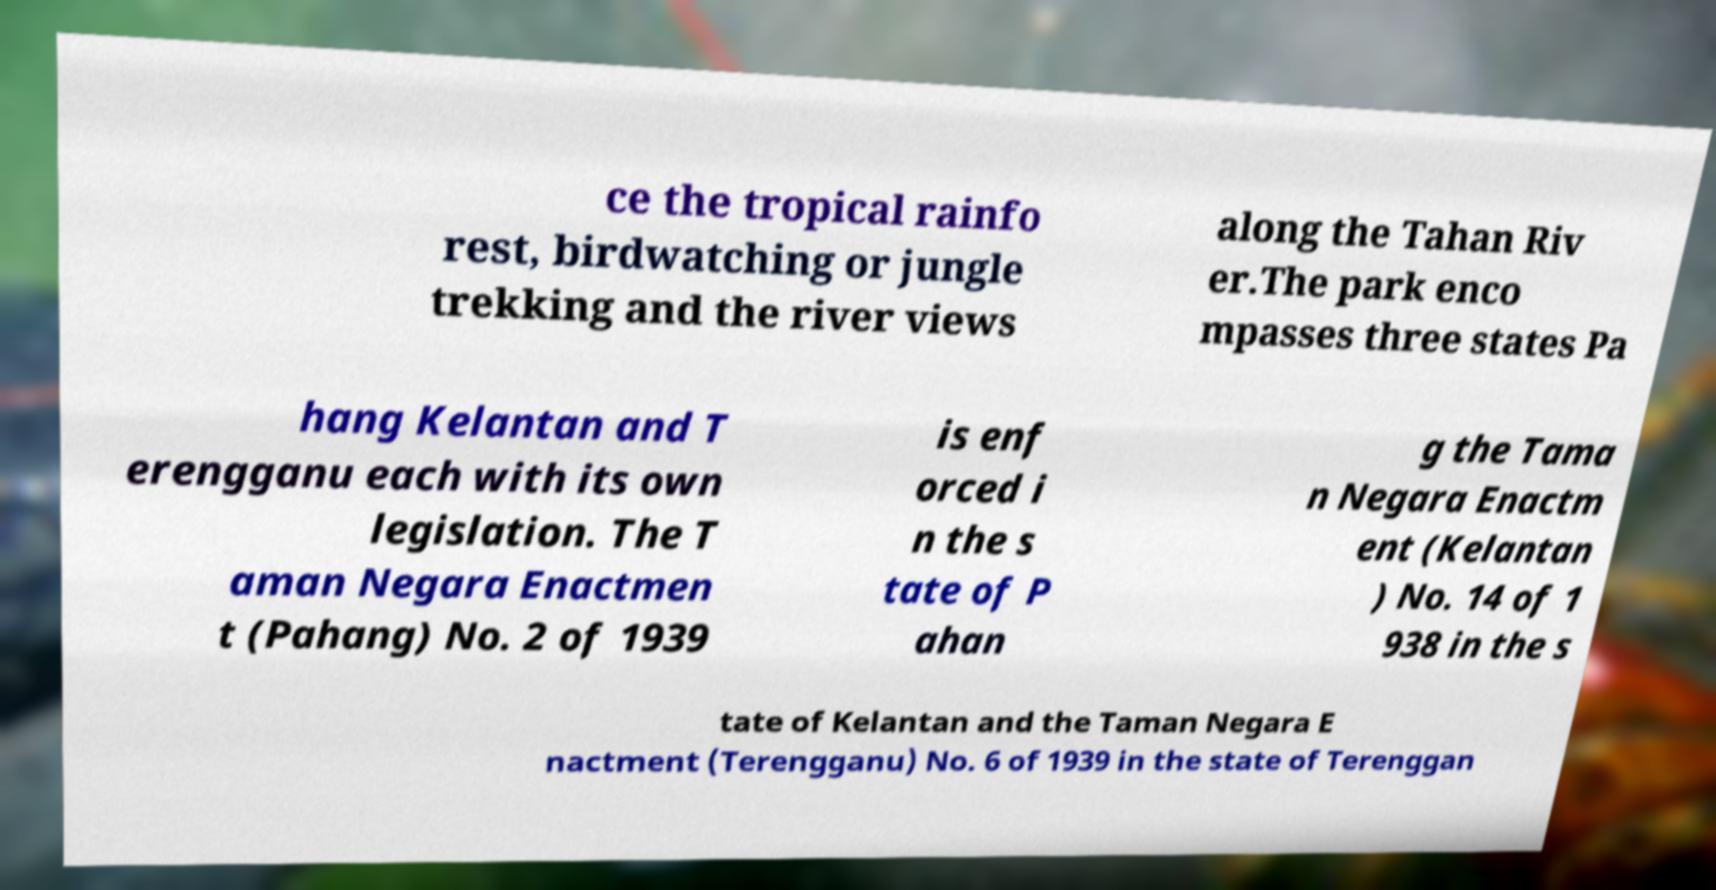Please read and relay the text visible in this image. What does it say? ce the tropical rainfo rest, birdwatching or jungle trekking and the river views along the Tahan Riv er.The park enco mpasses three states Pa hang Kelantan and T erengganu each with its own legislation. The T aman Negara Enactmen t (Pahang) No. 2 of 1939 is enf orced i n the s tate of P ahan g the Tama n Negara Enactm ent (Kelantan ) No. 14 of 1 938 in the s tate of Kelantan and the Taman Negara E nactment (Terengganu) No. 6 of 1939 in the state of Terenggan 